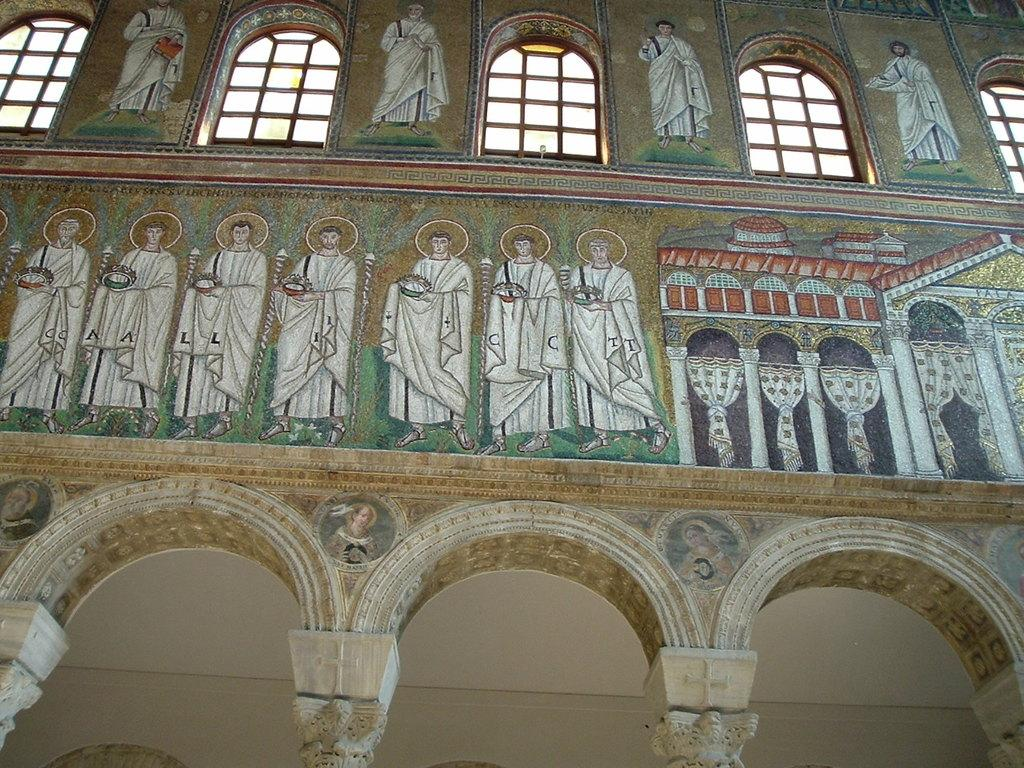What architectural feature can be seen at the bottom side of the image? There are arches at the bottom side of the image. What is depicted on the wall in the image? There is a painting on the wall. What type of openings are present at the top side of the image? There are windows at the top side of the image. What type of badge can be seen on the painting in the image? There is no badge present on the painting in the image. Can you tell me how many bags of popcorn are visible in the image? There are no bags of popcorn present in the image. 